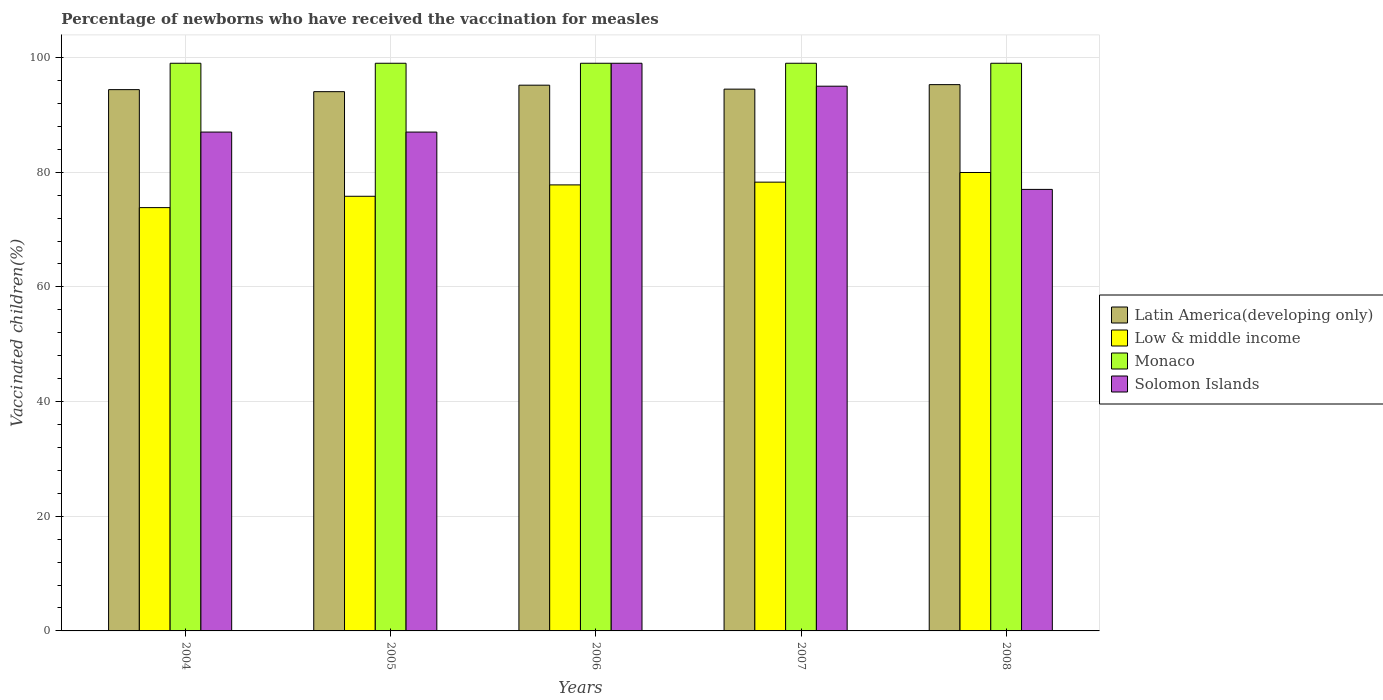What is the label of the 1st group of bars from the left?
Offer a terse response. 2004. What is the percentage of vaccinated children in Low & middle income in 2004?
Provide a short and direct response. 73.82. In which year was the percentage of vaccinated children in Latin America(developing only) minimum?
Keep it short and to the point. 2005. What is the total percentage of vaccinated children in Monaco in the graph?
Give a very brief answer. 495. What is the difference between the percentage of vaccinated children in Low & middle income in 2005 and that in 2008?
Make the answer very short. -4.15. What is the difference between the percentage of vaccinated children in Low & middle income in 2006 and the percentage of vaccinated children in Solomon Islands in 2004?
Keep it short and to the point. -9.21. What is the average percentage of vaccinated children in Solomon Islands per year?
Offer a terse response. 89. In how many years, is the percentage of vaccinated children in Latin America(developing only) greater than 20 %?
Offer a terse response. 5. What is the ratio of the percentage of vaccinated children in Latin America(developing only) in 2006 to that in 2007?
Offer a very short reply. 1.01. What is the difference between the highest and the second highest percentage of vaccinated children in Low & middle income?
Give a very brief answer. 1.69. What is the difference between the highest and the lowest percentage of vaccinated children in Solomon Islands?
Offer a terse response. 22. In how many years, is the percentage of vaccinated children in Solomon Islands greater than the average percentage of vaccinated children in Solomon Islands taken over all years?
Offer a very short reply. 2. Is the sum of the percentage of vaccinated children in Solomon Islands in 2006 and 2008 greater than the maximum percentage of vaccinated children in Low & middle income across all years?
Keep it short and to the point. Yes. Is it the case that in every year, the sum of the percentage of vaccinated children in Low & middle income and percentage of vaccinated children in Monaco is greater than the sum of percentage of vaccinated children in Solomon Islands and percentage of vaccinated children in Latin America(developing only)?
Your response must be concise. No. What does the 4th bar from the left in 2004 represents?
Provide a succinct answer. Solomon Islands. What does the 3rd bar from the right in 2007 represents?
Ensure brevity in your answer.  Low & middle income. Is it the case that in every year, the sum of the percentage of vaccinated children in Low & middle income and percentage of vaccinated children in Monaco is greater than the percentage of vaccinated children in Solomon Islands?
Keep it short and to the point. Yes. How many bars are there?
Provide a succinct answer. 20. Are all the bars in the graph horizontal?
Offer a very short reply. No. How many years are there in the graph?
Provide a succinct answer. 5. Are the values on the major ticks of Y-axis written in scientific E-notation?
Offer a terse response. No. Does the graph contain grids?
Your response must be concise. Yes. How many legend labels are there?
Keep it short and to the point. 4. How are the legend labels stacked?
Ensure brevity in your answer.  Vertical. What is the title of the graph?
Your answer should be very brief. Percentage of newborns who have received the vaccination for measles. Does "Luxembourg" appear as one of the legend labels in the graph?
Keep it short and to the point. No. What is the label or title of the X-axis?
Make the answer very short. Years. What is the label or title of the Y-axis?
Give a very brief answer. Vaccinated children(%). What is the Vaccinated children(%) of Latin America(developing only) in 2004?
Ensure brevity in your answer.  94.4. What is the Vaccinated children(%) in Low & middle income in 2004?
Provide a succinct answer. 73.82. What is the Vaccinated children(%) of Monaco in 2004?
Your response must be concise. 99. What is the Vaccinated children(%) in Latin America(developing only) in 2005?
Ensure brevity in your answer.  94.05. What is the Vaccinated children(%) of Low & middle income in 2005?
Offer a terse response. 75.8. What is the Vaccinated children(%) in Latin America(developing only) in 2006?
Make the answer very short. 95.18. What is the Vaccinated children(%) of Low & middle income in 2006?
Provide a short and direct response. 77.79. What is the Vaccinated children(%) in Latin America(developing only) in 2007?
Your response must be concise. 94.49. What is the Vaccinated children(%) in Low & middle income in 2007?
Your response must be concise. 78.27. What is the Vaccinated children(%) of Monaco in 2007?
Your response must be concise. 99. What is the Vaccinated children(%) in Solomon Islands in 2007?
Keep it short and to the point. 95. What is the Vaccinated children(%) in Latin America(developing only) in 2008?
Your answer should be compact. 95.27. What is the Vaccinated children(%) of Low & middle income in 2008?
Keep it short and to the point. 79.95. What is the Vaccinated children(%) of Monaco in 2008?
Give a very brief answer. 99. What is the Vaccinated children(%) in Solomon Islands in 2008?
Your answer should be very brief. 77. Across all years, what is the maximum Vaccinated children(%) in Latin America(developing only)?
Your response must be concise. 95.27. Across all years, what is the maximum Vaccinated children(%) of Low & middle income?
Your answer should be very brief. 79.95. Across all years, what is the maximum Vaccinated children(%) of Solomon Islands?
Give a very brief answer. 99. Across all years, what is the minimum Vaccinated children(%) in Latin America(developing only)?
Your answer should be very brief. 94.05. Across all years, what is the minimum Vaccinated children(%) of Low & middle income?
Your response must be concise. 73.82. Across all years, what is the minimum Vaccinated children(%) of Monaco?
Give a very brief answer. 99. What is the total Vaccinated children(%) of Latin America(developing only) in the graph?
Offer a terse response. 473.39. What is the total Vaccinated children(%) of Low & middle income in the graph?
Keep it short and to the point. 385.63. What is the total Vaccinated children(%) of Monaco in the graph?
Ensure brevity in your answer.  495. What is the total Vaccinated children(%) in Solomon Islands in the graph?
Ensure brevity in your answer.  445. What is the difference between the Vaccinated children(%) of Latin America(developing only) in 2004 and that in 2005?
Your response must be concise. 0.36. What is the difference between the Vaccinated children(%) of Low & middle income in 2004 and that in 2005?
Keep it short and to the point. -1.98. What is the difference between the Vaccinated children(%) of Monaco in 2004 and that in 2005?
Provide a succinct answer. 0. What is the difference between the Vaccinated children(%) of Solomon Islands in 2004 and that in 2005?
Offer a terse response. 0. What is the difference between the Vaccinated children(%) of Latin America(developing only) in 2004 and that in 2006?
Provide a short and direct response. -0.78. What is the difference between the Vaccinated children(%) of Low & middle income in 2004 and that in 2006?
Your answer should be very brief. -3.96. What is the difference between the Vaccinated children(%) of Monaco in 2004 and that in 2006?
Provide a succinct answer. 0. What is the difference between the Vaccinated children(%) in Latin America(developing only) in 2004 and that in 2007?
Your response must be concise. -0.09. What is the difference between the Vaccinated children(%) of Low & middle income in 2004 and that in 2007?
Your answer should be compact. -4.44. What is the difference between the Vaccinated children(%) in Solomon Islands in 2004 and that in 2007?
Provide a short and direct response. -8. What is the difference between the Vaccinated children(%) in Latin America(developing only) in 2004 and that in 2008?
Make the answer very short. -0.87. What is the difference between the Vaccinated children(%) in Low & middle income in 2004 and that in 2008?
Offer a very short reply. -6.13. What is the difference between the Vaccinated children(%) of Latin America(developing only) in 2005 and that in 2006?
Give a very brief answer. -1.13. What is the difference between the Vaccinated children(%) in Low & middle income in 2005 and that in 2006?
Keep it short and to the point. -1.98. What is the difference between the Vaccinated children(%) of Monaco in 2005 and that in 2006?
Keep it short and to the point. 0. What is the difference between the Vaccinated children(%) of Solomon Islands in 2005 and that in 2006?
Ensure brevity in your answer.  -12. What is the difference between the Vaccinated children(%) of Latin America(developing only) in 2005 and that in 2007?
Give a very brief answer. -0.44. What is the difference between the Vaccinated children(%) of Low & middle income in 2005 and that in 2007?
Ensure brevity in your answer.  -2.46. What is the difference between the Vaccinated children(%) in Monaco in 2005 and that in 2007?
Make the answer very short. 0. What is the difference between the Vaccinated children(%) in Solomon Islands in 2005 and that in 2007?
Your answer should be compact. -8. What is the difference between the Vaccinated children(%) of Latin America(developing only) in 2005 and that in 2008?
Your response must be concise. -1.23. What is the difference between the Vaccinated children(%) of Low & middle income in 2005 and that in 2008?
Make the answer very short. -4.15. What is the difference between the Vaccinated children(%) of Monaco in 2005 and that in 2008?
Your answer should be compact. 0. What is the difference between the Vaccinated children(%) in Latin America(developing only) in 2006 and that in 2007?
Make the answer very short. 0.69. What is the difference between the Vaccinated children(%) in Low & middle income in 2006 and that in 2007?
Offer a very short reply. -0.48. What is the difference between the Vaccinated children(%) of Solomon Islands in 2006 and that in 2007?
Give a very brief answer. 4. What is the difference between the Vaccinated children(%) in Latin America(developing only) in 2006 and that in 2008?
Ensure brevity in your answer.  -0.09. What is the difference between the Vaccinated children(%) of Low & middle income in 2006 and that in 2008?
Your answer should be very brief. -2.16. What is the difference between the Vaccinated children(%) of Solomon Islands in 2006 and that in 2008?
Your answer should be compact. 22. What is the difference between the Vaccinated children(%) of Latin America(developing only) in 2007 and that in 2008?
Your answer should be very brief. -0.78. What is the difference between the Vaccinated children(%) in Low & middle income in 2007 and that in 2008?
Keep it short and to the point. -1.69. What is the difference between the Vaccinated children(%) in Solomon Islands in 2007 and that in 2008?
Ensure brevity in your answer.  18. What is the difference between the Vaccinated children(%) in Latin America(developing only) in 2004 and the Vaccinated children(%) in Low & middle income in 2005?
Offer a terse response. 18.6. What is the difference between the Vaccinated children(%) of Latin America(developing only) in 2004 and the Vaccinated children(%) of Monaco in 2005?
Your answer should be compact. -4.6. What is the difference between the Vaccinated children(%) of Latin America(developing only) in 2004 and the Vaccinated children(%) of Solomon Islands in 2005?
Make the answer very short. 7.4. What is the difference between the Vaccinated children(%) of Low & middle income in 2004 and the Vaccinated children(%) of Monaco in 2005?
Give a very brief answer. -25.18. What is the difference between the Vaccinated children(%) of Low & middle income in 2004 and the Vaccinated children(%) of Solomon Islands in 2005?
Give a very brief answer. -13.18. What is the difference between the Vaccinated children(%) in Monaco in 2004 and the Vaccinated children(%) in Solomon Islands in 2005?
Give a very brief answer. 12. What is the difference between the Vaccinated children(%) of Latin America(developing only) in 2004 and the Vaccinated children(%) of Low & middle income in 2006?
Give a very brief answer. 16.61. What is the difference between the Vaccinated children(%) in Latin America(developing only) in 2004 and the Vaccinated children(%) in Monaco in 2006?
Give a very brief answer. -4.6. What is the difference between the Vaccinated children(%) in Latin America(developing only) in 2004 and the Vaccinated children(%) in Solomon Islands in 2006?
Your response must be concise. -4.6. What is the difference between the Vaccinated children(%) in Low & middle income in 2004 and the Vaccinated children(%) in Monaco in 2006?
Offer a very short reply. -25.18. What is the difference between the Vaccinated children(%) of Low & middle income in 2004 and the Vaccinated children(%) of Solomon Islands in 2006?
Offer a terse response. -25.18. What is the difference between the Vaccinated children(%) of Monaco in 2004 and the Vaccinated children(%) of Solomon Islands in 2006?
Provide a succinct answer. 0. What is the difference between the Vaccinated children(%) in Latin America(developing only) in 2004 and the Vaccinated children(%) in Low & middle income in 2007?
Ensure brevity in your answer.  16.14. What is the difference between the Vaccinated children(%) of Latin America(developing only) in 2004 and the Vaccinated children(%) of Monaco in 2007?
Your answer should be very brief. -4.6. What is the difference between the Vaccinated children(%) in Latin America(developing only) in 2004 and the Vaccinated children(%) in Solomon Islands in 2007?
Make the answer very short. -0.6. What is the difference between the Vaccinated children(%) in Low & middle income in 2004 and the Vaccinated children(%) in Monaco in 2007?
Provide a succinct answer. -25.18. What is the difference between the Vaccinated children(%) of Low & middle income in 2004 and the Vaccinated children(%) of Solomon Islands in 2007?
Your response must be concise. -21.18. What is the difference between the Vaccinated children(%) in Monaco in 2004 and the Vaccinated children(%) in Solomon Islands in 2007?
Keep it short and to the point. 4. What is the difference between the Vaccinated children(%) in Latin America(developing only) in 2004 and the Vaccinated children(%) in Low & middle income in 2008?
Your answer should be very brief. 14.45. What is the difference between the Vaccinated children(%) in Latin America(developing only) in 2004 and the Vaccinated children(%) in Monaco in 2008?
Provide a succinct answer. -4.6. What is the difference between the Vaccinated children(%) in Latin America(developing only) in 2004 and the Vaccinated children(%) in Solomon Islands in 2008?
Provide a succinct answer. 17.4. What is the difference between the Vaccinated children(%) of Low & middle income in 2004 and the Vaccinated children(%) of Monaco in 2008?
Your answer should be very brief. -25.18. What is the difference between the Vaccinated children(%) of Low & middle income in 2004 and the Vaccinated children(%) of Solomon Islands in 2008?
Your response must be concise. -3.18. What is the difference between the Vaccinated children(%) of Latin America(developing only) in 2005 and the Vaccinated children(%) of Low & middle income in 2006?
Give a very brief answer. 16.26. What is the difference between the Vaccinated children(%) in Latin America(developing only) in 2005 and the Vaccinated children(%) in Monaco in 2006?
Ensure brevity in your answer.  -4.95. What is the difference between the Vaccinated children(%) of Latin America(developing only) in 2005 and the Vaccinated children(%) of Solomon Islands in 2006?
Offer a very short reply. -4.95. What is the difference between the Vaccinated children(%) in Low & middle income in 2005 and the Vaccinated children(%) in Monaco in 2006?
Give a very brief answer. -23.2. What is the difference between the Vaccinated children(%) in Low & middle income in 2005 and the Vaccinated children(%) in Solomon Islands in 2006?
Give a very brief answer. -23.2. What is the difference between the Vaccinated children(%) of Monaco in 2005 and the Vaccinated children(%) of Solomon Islands in 2006?
Provide a short and direct response. 0. What is the difference between the Vaccinated children(%) of Latin America(developing only) in 2005 and the Vaccinated children(%) of Low & middle income in 2007?
Offer a terse response. 15.78. What is the difference between the Vaccinated children(%) of Latin America(developing only) in 2005 and the Vaccinated children(%) of Monaco in 2007?
Provide a succinct answer. -4.95. What is the difference between the Vaccinated children(%) in Latin America(developing only) in 2005 and the Vaccinated children(%) in Solomon Islands in 2007?
Make the answer very short. -0.95. What is the difference between the Vaccinated children(%) in Low & middle income in 2005 and the Vaccinated children(%) in Monaco in 2007?
Provide a short and direct response. -23.2. What is the difference between the Vaccinated children(%) in Low & middle income in 2005 and the Vaccinated children(%) in Solomon Islands in 2007?
Your answer should be compact. -19.2. What is the difference between the Vaccinated children(%) in Monaco in 2005 and the Vaccinated children(%) in Solomon Islands in 2007?
Make the answer very short. 4. What is the difference between the Vaccinated children(%) in Latin America(developing only) in 2005 and the Vaccinated children(%) in Low & middle income in 2008?
Keep it short and to the point. 14.09. What is the difference between the Vaccinated children(%) in Latin America(developing only) in 2005 and the Vaccinated children(%) in Monaco in 2008?
Offer a very short reply. -4.95. What is the difference between the Vaccinated children(%) in Latin America(developing only) in 2005 and the Vaccinated children(%) in Solomon Islands in 2008?
Offer a terse response. 17.05. What is the difference between the Vaccinated children(%) in Low & middle income in 2005 and the Vaccinated children(%) in Monaco in 2008?
Keep it short and to the point. -23.2. What is the difference between the Vaccinated children(%) of Low & middle income in 2005 and the Vaccinated children(%) of Solomon Islands in 2008?
Make the answer very short. -1.2. What is the difference between the Vaccinated children(%) of Latin America(developing only) in 2006 and the Vaccinated children(%) of Low & middle income in 2007?
Offer a very short reply. 16.91. What is the difference between the Vaccinated children(%) of Latin America(developing only) in 2006 and the Vaccinated children(%) of Monaco in 2007?
Your answer should be compact. -3.82. What is the difference between the Vaccinated children(%) in Latin America(developing only) in 2006 and the Vaccinated children(%) in Solomon Islands in 2007?
Your response must be concise. 0.18. What is the difference between the Vaccinated children(%) of Low & middle income in 2006 and the Vaccinated children(%) of Monaco in 2007?
Your answer should be compact. -21.21. What is the difference between the Vaccinated children(%) of Low & middle income in 2006 and the Vaccinated children(%) of Solomon Islands in 2007?
Provide a succinct answer. -17.21. What is the difference between the Vaccinated children(%) of Monaco in 2006 and the Vaccinated children(%) of Solomon Islands in 2007?
Ensure brevity in your answer.  4. What is the difference between the Vaccinated children(%) of Latin America(developing only) in 2006 and the Vaccinated children(%) of Low & middle income in 2008?
Keep it short and to the point. 15.23. What is the difference between the Vaccinated children(%) of Latin America(developing only) in 2006 and the Vaccinated children(%) of Monaco in 2008?
Your response must be concise. -3.82. What is the difference between the Vaccinated children(%) in Latin America(developing only) in 2006 and the Vaccinated children(%) in Solomon Islands in 2008?
Your response must be concise. 18.18. What is the difference between the Vaccinated children(%) of Low & middle income in 2006 and the Vaccinated children(%) of Monaco in 2008?
Provide a short and direct response. -21.21. What is the difference between the Vaccinated children(%) of Low & middle income in 2006 and the Vaccinated children(%) of Solomon Islands in 2008?
Your answer should be compact. 0.79. What is the difference between the Vaccinated children(%) of Monaco in 2006 and the Vaccinated children(%) of Solomon Islands in 2008?
Offer a terse response. 22. What is the difference between the Vaccinated children(%) of Latin America(developing only) in 2007 and the Vaccinated children(%) of Low & middle income in 2008?
Give a very brief answer. 14.54. What is the difference between the Vaccinated children(%) in Latin America(developing only) in 2007 and the Vaccinated children(%) in Monaco in 2008?
Make the answer very short. -4.51. What is the difference between the Vaccinated children(%) in Latin America(developing only) in 2007 and the Vaccinated children(%) in Solomon Islands in 2008?
Offer a very short reply. 17.49. What is the difference between the Vaccinated children(%) in Low & middle income in 2007 and the Vaccinated children(%) in Monaco in 2008?
Offer a very short reply. -20.73. What is the difference between the Vaccinated children(%) in Low & middle income in 2007 and the Vaccinated children(%) in Solomon Islands in 2008?
Provide a succinct answer. 1.27. What is the difference between the Vaccinated children(%) in Monaco in 2007 and the Vaccinated children(%) in Solomon Islands in 2008?
Offer a very short reply. 22. What is the average Vaccinated children(%) in Latin America(developing only) per year?
Your answer should be compact. 94.68. What is the average Vaccinated children(%) of Low & middle income per year?
Give a very brief answer. 77.13. What is the average Vaccinated children(%) in Monaco per year?
Make the answer very short. 99. What is the average Vaccinated children(%) of Solomon Islands per year?
Provide a succinct answer. 89. In the year 2004, what is the difference between the Vaccinated children(%) in Latin America(developing only) and Vaccinated children(%) in Low & middle income?
Offer a very short reply. 20.58. In the year 2004, what is the difference between the Vaccinated children(%) of Latin America(developing only) and Vaccinated children(%) of Monaco?
Offer a very short reply. -4.6. In the year 2004, what is the difference between the Vaccinated children(%) in Latin America(developing only) and Vaccinated children(%) in Solomon Islands?
Your response must be concise. 7.4. In the year 2004, what is the difference between the Vaccinated children(%) of Low & middle income and Vaccinated children(%) of Monaco?
Your answer should be very brief. -25.18. In the year 2004, what is the difference between the Vaccinated children(%) in Low & middle income and Vaccinated children(%) in Solomon Islands?
Offer a terse response. -13.18. In the year 2004, what is the difference between the Vaccinated children(%) in Monaco and Vaccinated children(%) in Solomon Islands?
Offer a very short reply. 12. In the year 2005, what is the difference between the Vaccinated children(%) of Latin America(developing only) and Vaccinated children(%) of Low & middle income?
Offer a very short reply. 18.24. In the year 2005, what is the difference between the Vaccinated children(%) in Latin America(developing only) and Vaccinated children(%) in Monaco?
Provide a succinct answer. -4.95. In the year 2005, what is the difference between the Vaccinated children(%) in Latin America(developing only) and Vaccinated children(%) in Solomon Islands?
Ensure brevity in your answer.  7.05. In the year 2005, what is the difference between the Vaccinated children(%) of Low & middle income and Vaccinated children(%) of Monaco?
Give a very brief answer. -23.2. In the year 2005, what is the difference between the Vaccinated children(%) of Low & middle income and Vaccinated children(%) of Solomon Islands?
Keep it short and to the point. -11.2. In the year 2006, what is the difference between the Vaccinated children(%) in Latin America(developing only) and Vaccinated children(%) in Low & middle income?
Offer a very short reply. 17.39. In the year 2006, what is the difference between the Vaccinated children(%) in Latin America(developing only) and Vaccinated children(%) in Monaco?
Offer a terse response. -3.82. In the year 2006, what is the difference between the Vaccinated children(%) of Latin America(developing only) and Vaccinated children(%) of Solomon Islands?
Provide a short and direct response. -3.82. In the year 2006, what is the difference between the Vaccinated children(%) of Low & middle income and Vaccinated children(%) of Monaco?
Your response must be concise. -21.21. In the year 2006, what is the difference between the Vaccinated children(%) of Low & middle income and Vaccinated children(%) of Solomon Islands?
Provide a succinct answer. -21.21. In the year 2007, what is the difference between the Vaccinated children(%) in Latin America(developing only) and Vaccinated children(%) in Low & middle income?
Your answer should be very brief. 16.22. In the year 2007, what is the difference between the Vaccinated children(%) of Latin America(developing only) and Vaccinated children(%) of Monaco?
Make the answer very short. -4.51. In the year 2007, what is the difference between the Vaccinated children(%) of Latin America(developing only) and Vaccinated children(%) of Solomon Islands?
Make the answer very short. -0.51. In the year 2007, what is the difference between the Vaccinated children(%) of Low & middle income and Vaccinated children(%) of Monaco?
Make the answer very short. -20.73. In the year 2007, what is the difference between the Vaccinated children(%) of Low & middle income and Vaccinated children(%) of Solomon Islands?
Your answer should be very brief. -16.73. In the year 2007, what is the difference between the Vaccinated children(%) in Monaco and Vaccinated children(%) in Solomon Islands?
Provide a short and direct response. 4. In the year 2008, what is the difference between the Vaccinated children(%) of Latin America(developing only) and Vaccinated children(%) of Low & middle income?
Ensure brevity in your answer.  15.32. In the year 2008, what is the difference between the Vaccinated children(%) of Latin America(developing only) and Vaccinated children(%) of Monaco?
Ensure brevity in your answer.  -3.73. In the year 2008, what is the difference between the Vaccinated children(%) of Latin America(developing only) and Vaccinated children(%) of Solomon Islands?
Your answer should be very brief. 18.27. In the year 2008, what is the difference between the Vaccinated children(%) of Low & middle income and Vaccinated children(%) of Monaco?
Your answer should be compact. -19.05. In the year 2008, what is the difference between the Vaccinated children(%) in Low & middle income and Vaccinated children(%) in Solomon Islands?
Provide a succinct answer. 2.95. In the year 2008, what is the difference between the Vaccinated children(%) in Monaco and Vaccinated children(%) in Solomon Islands?
Keep it short and to the point. 22. What is the ratio of the Vaccinated children(%) of Latin America(developing only) in 2004 to that in 2005?
Offer a terse response. 1. What is the ratio of the Vaccinated children(%) in Low & middle income in 2004 to that in 2005?
Give a very brief answer. 0.97. What is the ratio of the Vaccinated children(%) in Low & middle income in 2004 to that in 2006?
Offer a very short reply. 0.95. What is the ratio of the Vaccinated children(%) of Monaco in 2004 to that in 2006?
Make the answer very short. 1. What is the ratio of the Vaccinated children(%) of Solomon Islands in 2004 to that in 2006?
Make the answer very short. 0.88. What is the ratio of the Vaccinated children(%) in Low & middle income in 2004 to that in 2007?
Your response must be concise. 0.94. What is the ratio of the Vaccinated children(%) in Solomon Islands in 2004 to that in 2007?
Provide a short and direct response. 0.92. What is the ratio of the Vaccinated children(%) in Latin America(developing only) in 2004 to that in 2008?
Offer a terse response. 0.99. What is the ratio of the Vaccinated children(%) of Low & middle income in 2004 to that in 2008?
Make the answer very short. 0.92. What is the ratio of the Vaccinated children(%) of Monaco in 2004 to that in 2008?
Keep it short and to the point. 1. What is the ratio of the Vaccinated children(%) in Solomon Islands in 2004 to that in 2008?
Ensure brevity in your answer.  1.13. What is the ratio of the Vaccinated children(%) of Low & middle income in 2005 to that in 2006?
Make the answer very short. 0.97. What is the ratio of the Vaccinated children(%) of Solomon Islands in 2005 to that in 2006?
Make the answer very short. 0.88. What is the ratio of the Vaccinated children(%) of Latin America(developing only) in 2005 to that in 2007?
Provide a succinct answer. 1. What is the ratio of the Vaccinated children(%) of Low & middle income in 2005 to that in 2007?
Give a very brief answer. 0.97. What is the ratio of the Vaccinated children(%) of Monaco in 2005 to that in 2007?
Your answer should be compact. 1. What is the ratio of the Vaccinated children(%) of Solomon Islands in 2005 to that in 2007?
Provide a short and direct response. 0.92. What is the ratio of the Vaccinated children(%) in Latin America(developing only) in 2005 to that in 2008?
Make the answer very short. 0.99. What is the ratio of the Vaccinated children(%) in Low & middle income in 2005 to that in 2008?
Offer a terse response. 0.95. What is the ratio of the Vaccinated children(%) of Solomon Islands in 2005 to that in 2008?
Provide a succinct answer. 1.13. What is the ratio of the Vaccinated children(%) in Latin America(developing only) in 2006 to that in 2007?
Your answer should be compact. 1.01. What is the ratio of the Vaccinated children(%) of Solomon Islands in 2006 to that in 2007?
Your answer should be compact. 1.04. What is the ratio of the Vaccinated children(%) in Low & middle income in 2006 to that in 2008?
Provide a succinct answer. 0.97. What is the ratio of the Vaccinated children(%) in Monaco in 2006 to that in 2008?
Give a very brief answer. 1. What is the ratio of the Vaccinated children(%) of Solomon Islands in 2006 to that in 2008?
Provide a succinct answer. 1.29. What is the ratio of the Vaccinated children(%) in Latin America(developing only) in 2007 to that in 2008?
Give a very brief answer. 0.99. What is the ratio of the Vaccinated children(%) in Low & middle income in 2007 to that in 2008?
Provide a succinct answer. 0.98. What is the ratio of the Vaccinated children(%) in Solomon Islands in 2007 to that in 2008?
Ensure brevity in your answer.  1.23. What is the difference between the highest and the second highest Vaccinated children(%) in Latin America(developing only)?
Offer a terse response. 0.09. What is the difference between the highest and the second highest Vaccinated children(%) of Low & middle income?
Give a very brief answer. 1.69. What is the difference between the highest and the lowest Vaccinated children(%) of Latin America(developing only)?
Your answer should be compact. 1.23. What is the difference between the highest and the lowest Vaccinated children(%) in Low & middle income?
Your response must be concise. 6.13. 